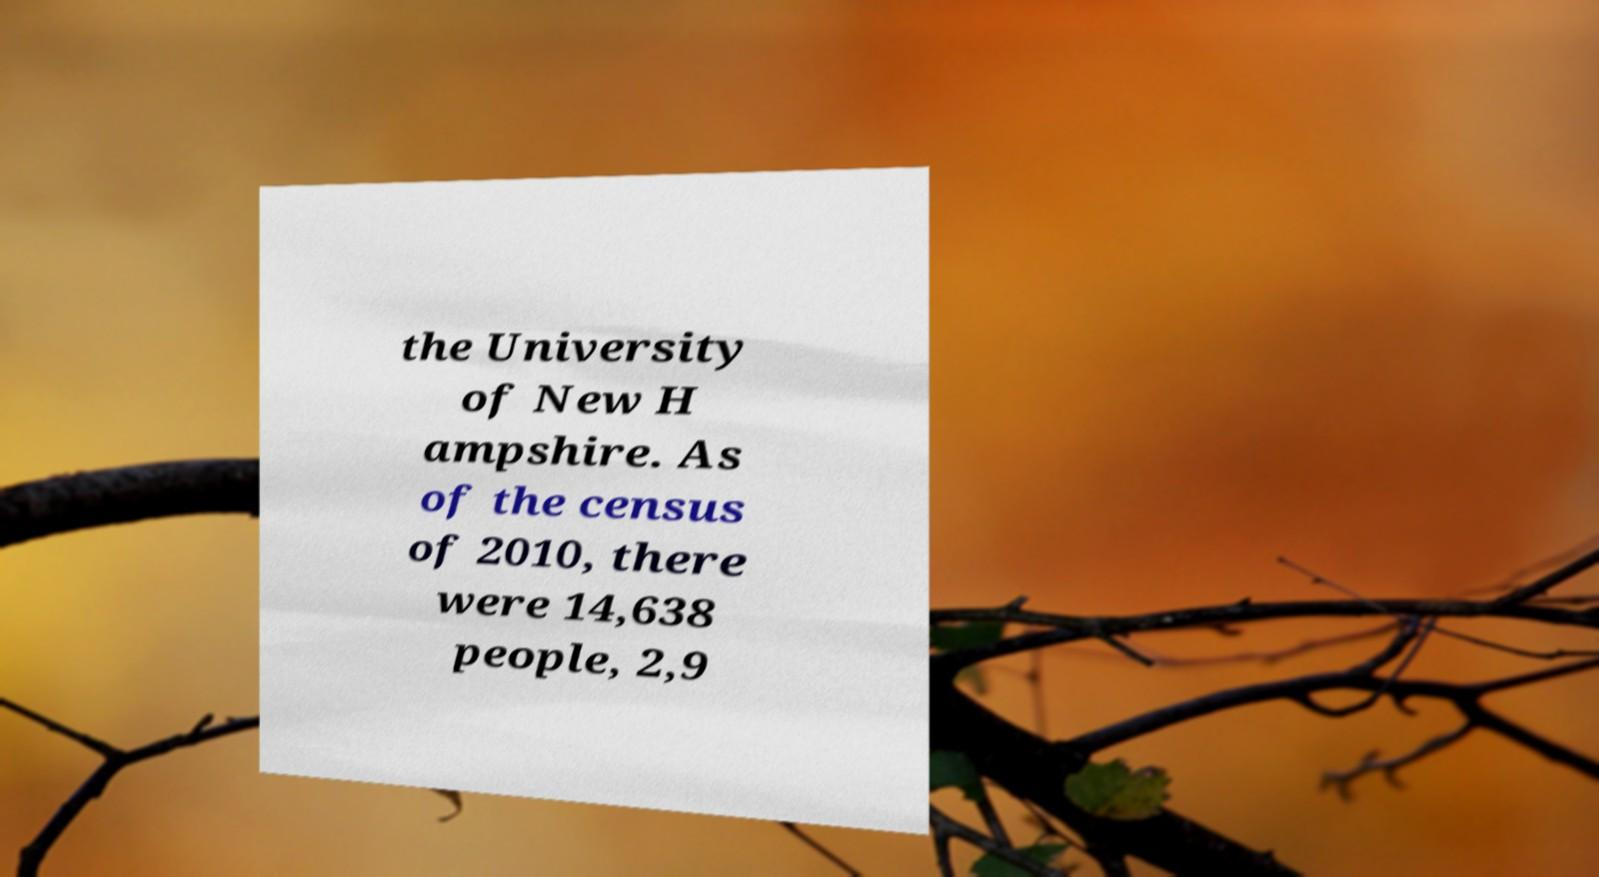Could you assist in decoding the text presented in this image and type it out clearly? the University of New H ampshire. As of the census of 2010, there were 14,638 people, 2,9 